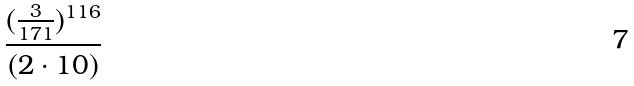Convert formula to latex. <formula><loc_0><loc_0><loc_500><loc_500>\frac { ( \frac { 3 } { 1 7 1 } ) ^ { 1 1 6 } } { ( 2 \cdot 1 0 ) }</formula> 